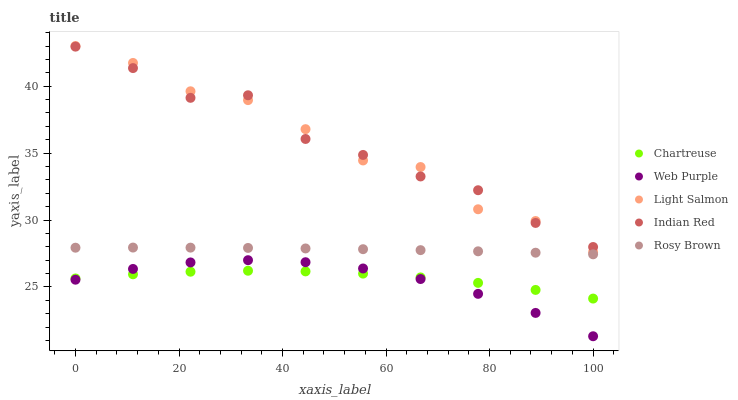Does Web Purple have the minimum area under the curve?
Answer yes or no. Yes. Does Light Salmon have the maximum area under the curve?
Answer yes or no. Yes. Does Rosy Brown have the minimum area under the curve?
Answer yes or no. No. Does Rosy Brown have the maximum area under the curve?
Answer yes or no. No. Is Rosy Brown the smoothest?
Answer yes or no. Yes. Is Light Salmon the roughest?
Answer yes or no. Yes. Is Web Purple the smoothest?
Answer yes or no. No. Is Web Purple the roughest?
Answer yes or no. No. Does Web Purple have the lowest value?
Answer yes or no. Yes. Does Rosy Brown have the lowest value?
Answer yes or no. No. Does Light Salmon have the highest value?
Answer yes or no. Yes. Does Rosy Brown have the highest value?
Answer yes or no. No. Is Chartreuse less than Light Salmon?
Answer yes or no. Yes. Is Light Salmon greater than Rosy Brown?
Answer yes or no. Yes. Does Indian Red intersect Light Salmon?
Answer yes or no. Yes. Is Indian Red less than Light Salmon?
Answer yes or no. No. Is Indian Red greater than Light Salmon?
Answer yes or no. No. Does Chartreuse intersect Light Salmon?
Answer yes or no. No. 